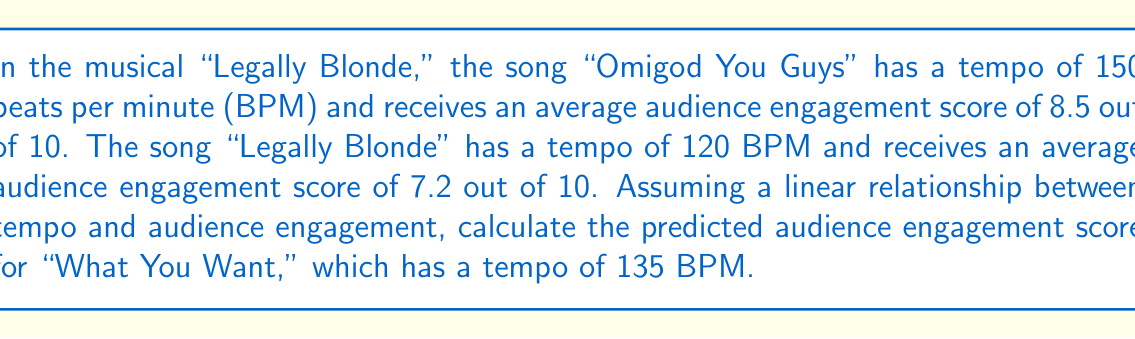Solve this math problem. To solve this problem, we'll use linear interpolation to find the audience engagement score for "What You Want" based on its tempo. Let's follow these steps:

1. Identify the known points:
   Point 1: (120 BPM, 7.2 engagement)
   Point 2: (150 BPM, 8.5 engagement)

2. Calculate the slope of the line:
   $$ m = \frac{y_2 - y_1}{x_2 - x_1} = \frac{8.5 - 7.2}{150 - 120} = \frac{1.3}{30} = 0.0433 $$

3. Use the point-slope form of a line to create the equation:
   $$ y - y_1 = m(x - x_1) $$
   $$ y - 7.2 = 0.0433(x - 120) $$

4. Simplify the equation:
   $$ y = 0.0433x - 5.196 + 7.2 $$
   $$ y = 0.0433x + 2.004 $$

5. Plug in the tempo of "What You Want" (135 BPM) to find the predicted engagement score:
   $$ y = 0.0433(135) + 2.004 $$
   $$ y = 5.8455 + 2.004 $$
   $$ y = 7.8495 $$

6. Round to two decimal places:
   $$ y \approx 7.85 $$

Therefore, the predicted audience engagement score for "What You Want" is approximately 7.85 out of 10.
Answer: 7.85 